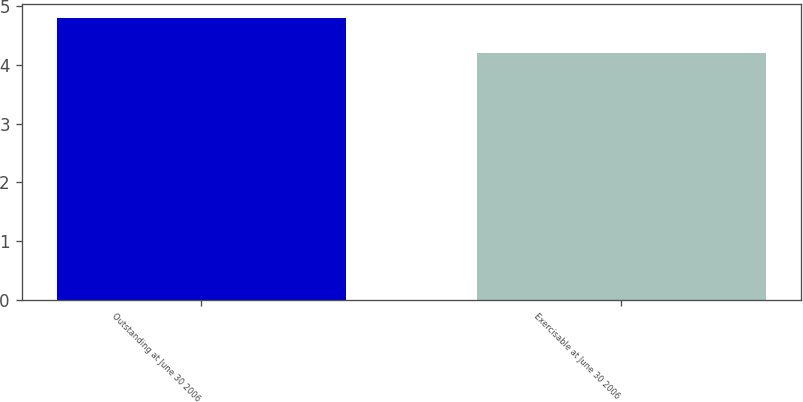Convert chart to OTSL. <chart><loc_0><loc_0><loc_500><loc_500><bar_chart><fcel>Outstanding at June 30 2006<fcel>Exercisable at June 30 2006<nl><fcel>4.8<fcel>4.2<nl></chart> 